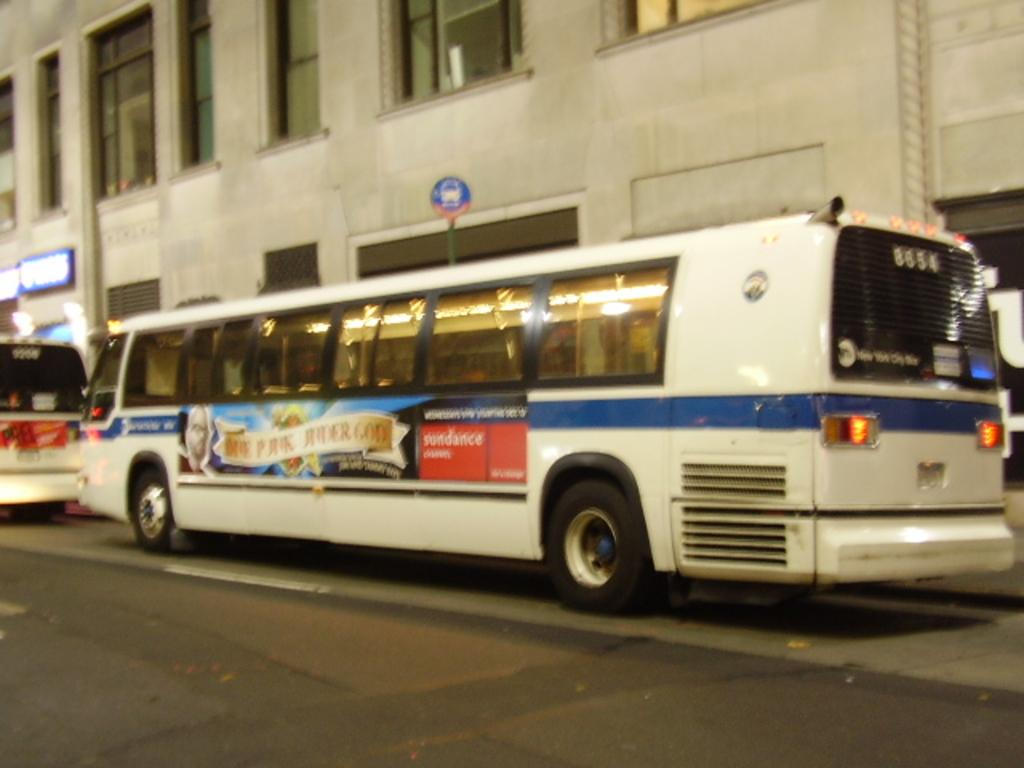What can be seen on the road in the image? There are vehicles on the road in the image. What is located in the background of the image? There is a board on a pole, at least one building, and hoardings on the wall in the background of the image. What architectural feature can be seen in the background of the image? There are windows visible in the background of the image. Can you hear the actor whispering in the image? There is no actor present in the image, and therefore no whispering can be heard. 